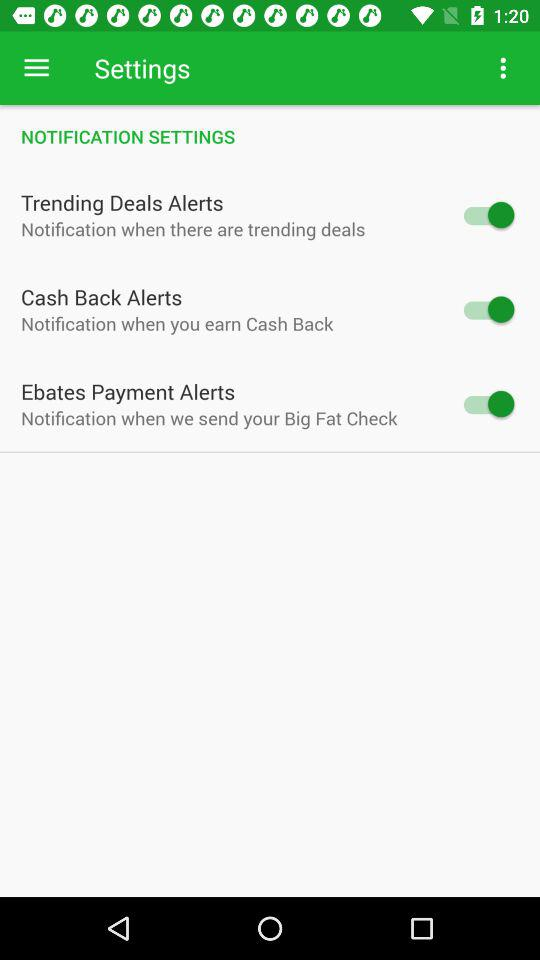What is the current status of the "Ebates Payment Alerts"? The current mode of the "Ebates Payment Alerts" is "on". 